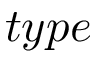<formula> <loc_0><loc_0><loc_500><loc_500>t y p e</formula> 